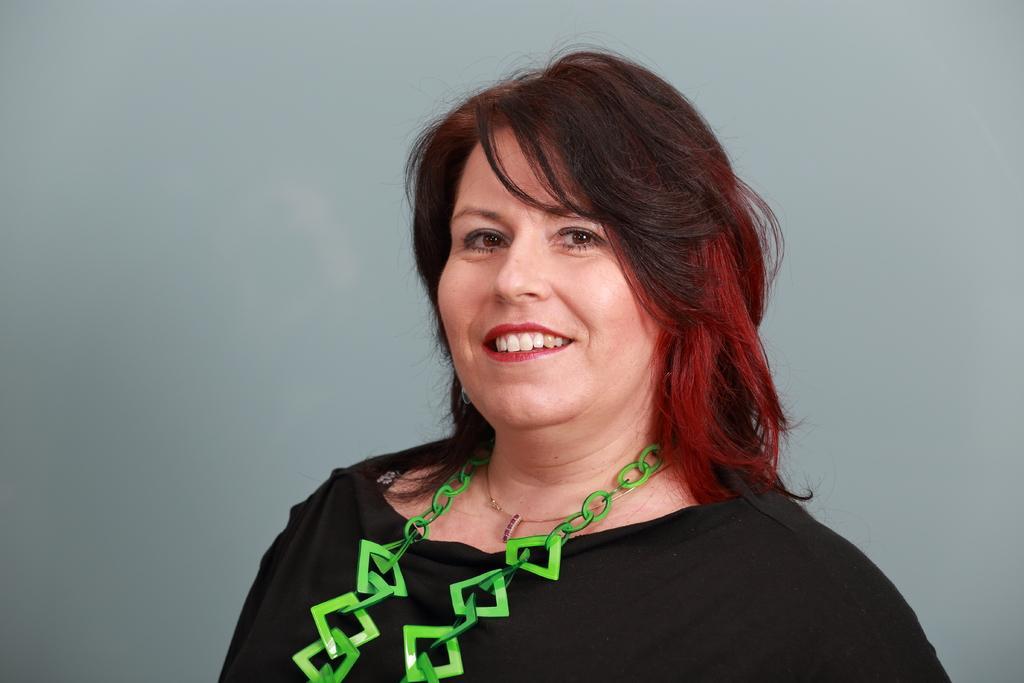In one or two sentences, can you explain what this image depicts? In this image there is a woman who is wearing the green colour necklace. 